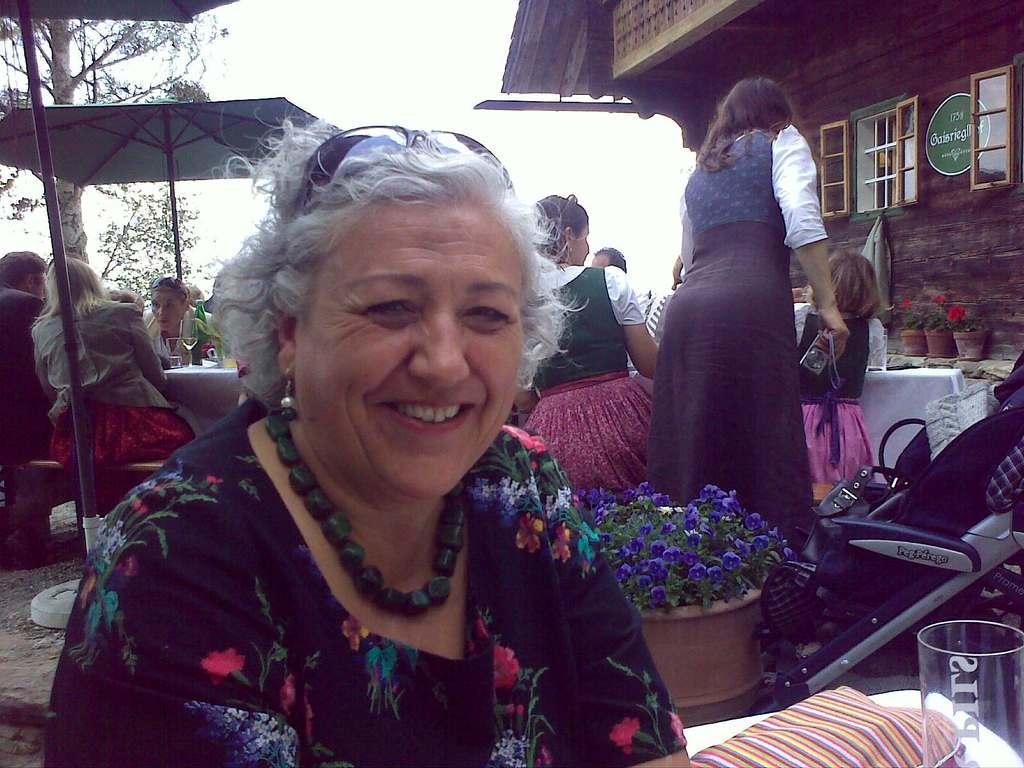Can you describe this image briefly? In the foreground I can see a group of people are sitting on the benches in front of a table, huts and houseplants. In the background I can see a building, windows, trees and the sky. This image is taken may be during a day in the hotel. 